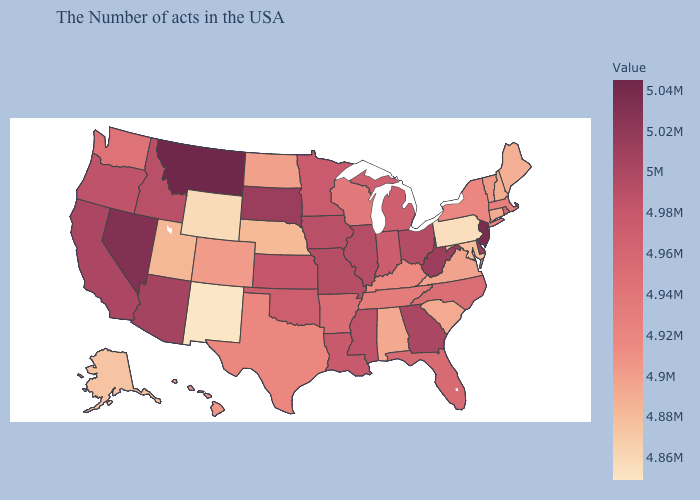Does New Mexico have the lowest value in the West?
Answer briefly. Yes. Among the states that border California , does Nevada have the highest value?
Short answer required. Yes. Does Montana have the highest value in the USA?
Concise answer only. Yes. Among the states that border Washington , which have the lowest value?
Write a very short answer. Oregon. Which states have the lowest value in the USA?
Write a very short answer. New Mexico. 